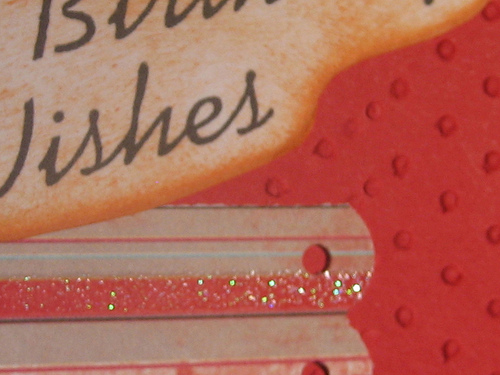<image>
Is the writing above the glitter? No. The writing is not positioned above the glitter. The vertical arrangement shows a different relationship. 